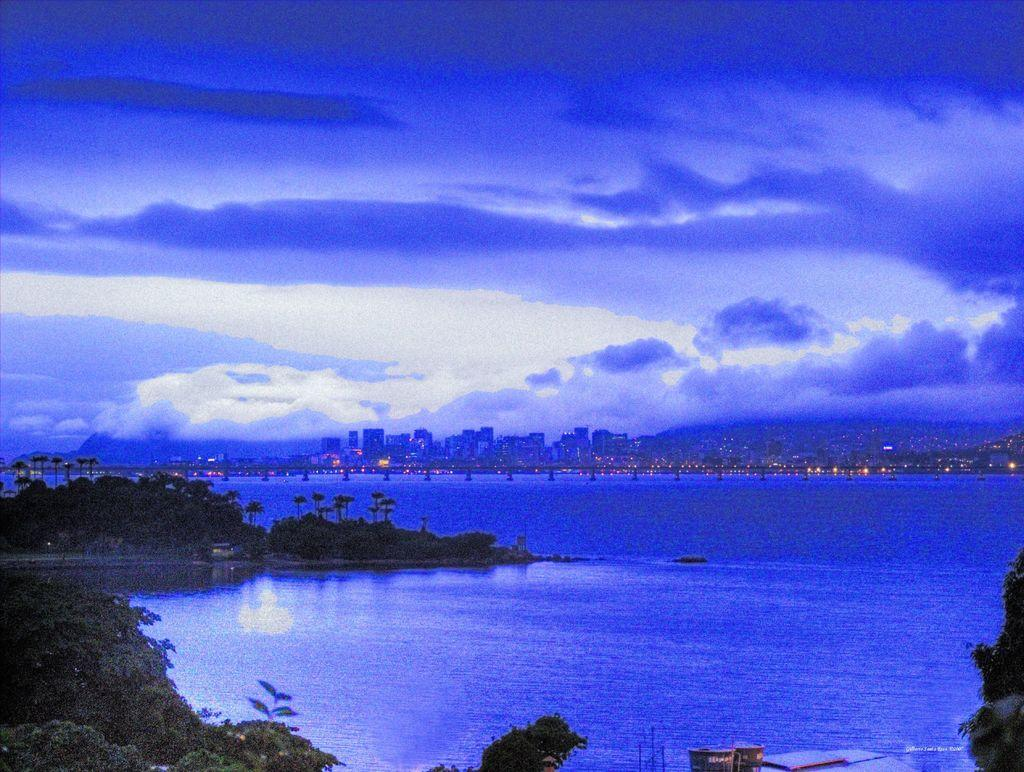What type of natural elements can be seen in the image? There are trees and water in the image. What man-made structure is present in the image? There is a bridge in the image. What type of human-made structures can be seen in the background of the image? There are buildings in the image. What type of illumination is present in the image? There are lights in the image. What part of the natural environment is visible in the image? The sky is visible in the image. What is the weight of the train in the image? There is no train present in the image. What type of joke is being told by the trees in the image? There are no jokes being told in the image; it features trees, water, a bridge, buildings, lights, and the sky. 